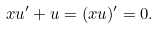<formula> <loc_0><loc_0><loc_500><loc_500>x u ^ { \prime } + u = ( x u ) ^ { \prime } = 0 .</formula> 